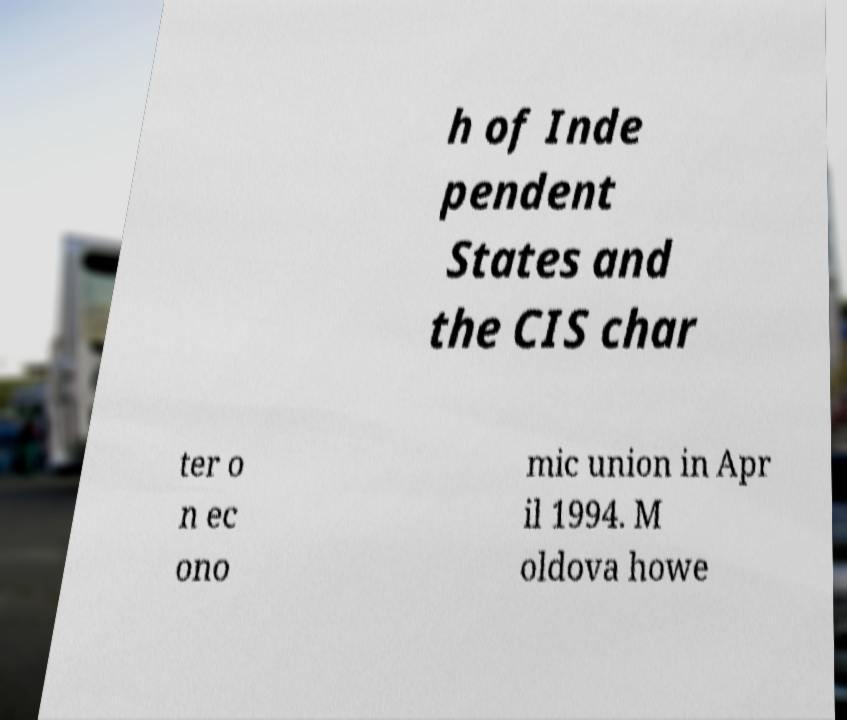What messages or text are displayed in this image? I need them in a readable, typed format. h of Inde pendent States and the CIS char ter o n ec ono mic union in Apr il 1994. M oldova howe 